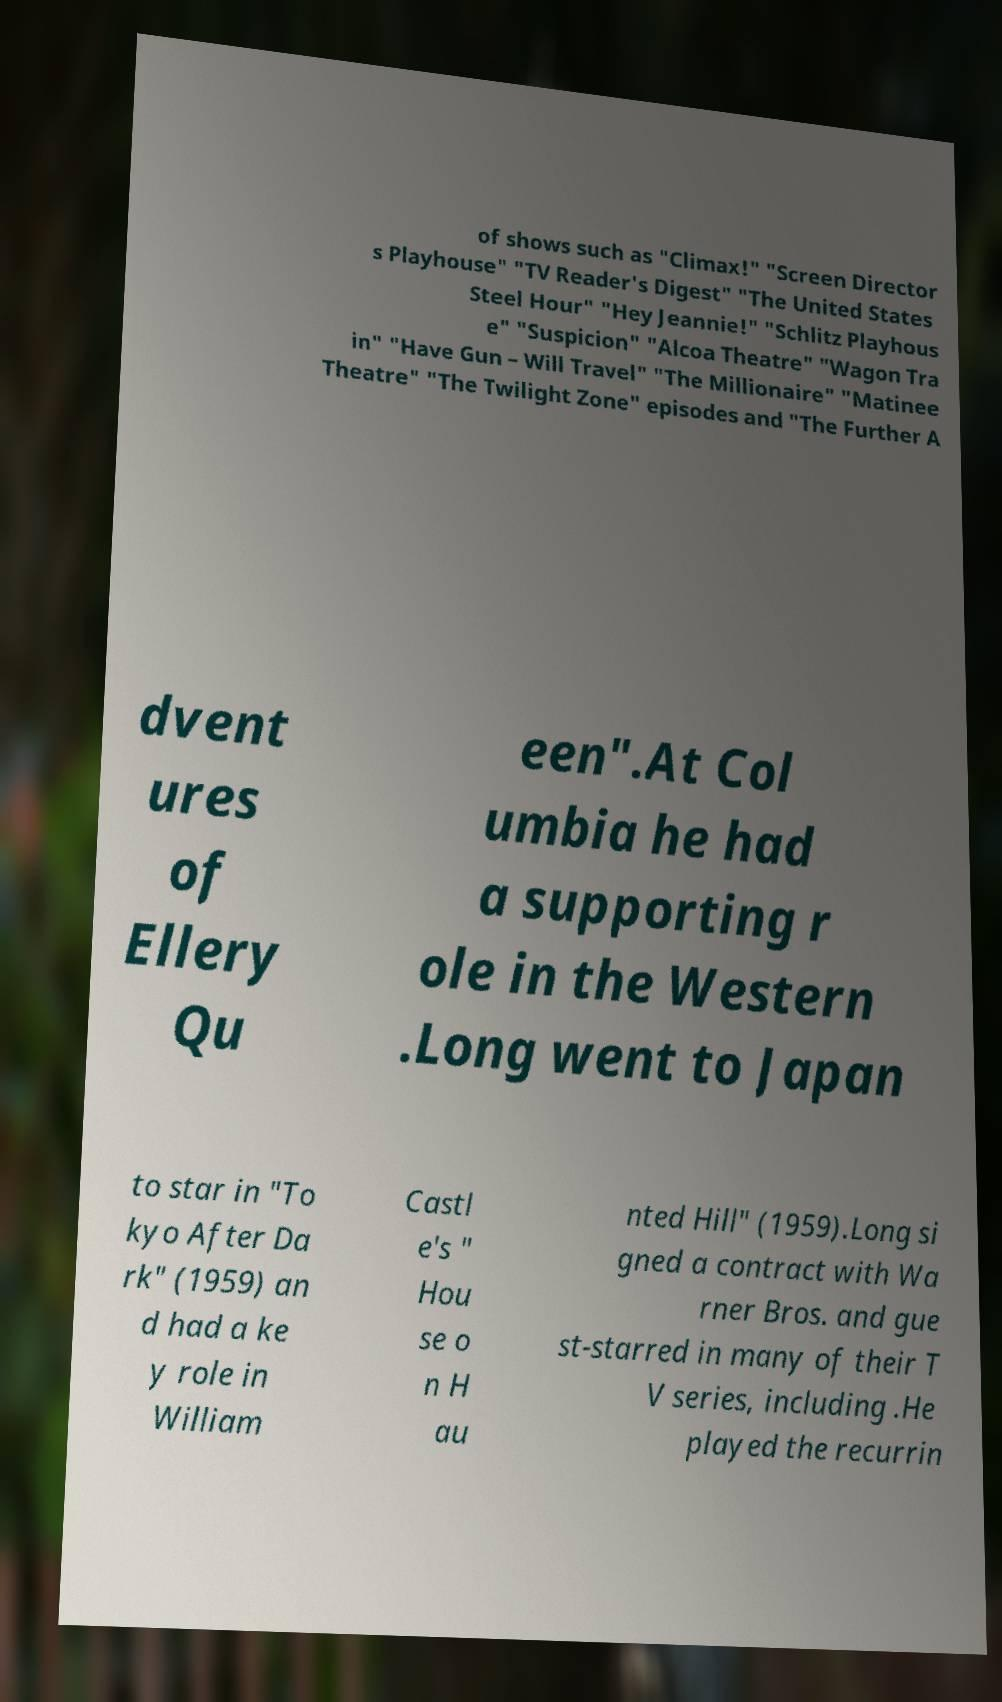Please read and relay the text visible in this image. What does it say? of shows such as "Climax!" "Screen Director s Playhouse" "TV Reader's Digest" "The United States Steel Hour" "Hey Jeannie!" "Schlitz Playhous e" "Suspicion" "Alcoa Theatre" "Wagon Tra in" "Have Gun – Will Travel" "The Millionaire" "Matinee Theatre" "The Twilight Zone" episodes and "The Further A dvent ures of Ellery Qu een".At Col umbia he had a supporting r ole in the Western .Long went to Japan to star in "To kyo After Da rk" (1959) an d had a ke y role in William Castl e's " Hou se o n H au nted Hill" (1959).Long si gned a contract with Wa rner Bros. and gue st-starred in many of their T V series, including .He played the recurrin 